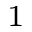Convert formula to latex. <formula><loc_0><loc_0><loc_500><loc_500>_ { 1 }</formula> 